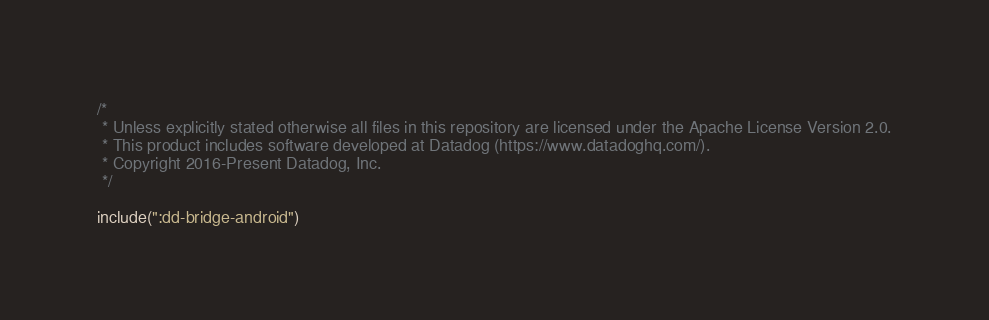Convert code to text. <code><loc_0><loc_0><loc_500><loc_500><_Kotlin_>/*
 * Unless explicitly stated otherwise all files in this repository are licensed under the Apache License Version 2.0.
 * This product includes software developed at Datadog (https://www.datadoghq.com/).
 * Copyright 2016-Present Datadog, Inc.
 */

include(":dd-bridge-android")
</code> 